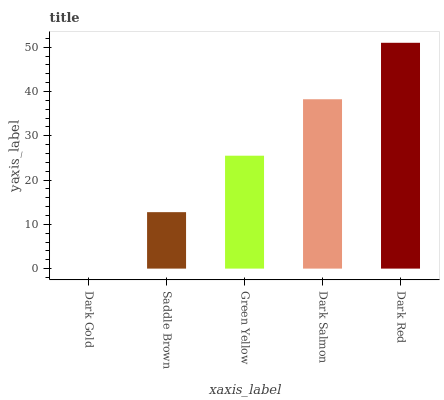Is Dark Gold the minimum?
Answer yes or no. Yes. Is Dark Red the maximum?
Answer yes or no. Yes. Is Saddle Brown the minimum?
Answer yes or no. No. Is Saddle Brown the maximum?
Answer yes or no. No. Is Saddle Brown greater than Dark Gold?
Answer yes or no. Yes. Is Dark Gold less than Saddle Brown?
Answer yes or no. Yes. Is Dark Gold greater than Saddle Brown?
Answer yes or no. No. Is Saddle Brown less than Dark Gold?
Answer yes or no. No. Is Green Yellow the high median?
Answer yes or no. Yes. Is Green Yellow the low median?
Answer yes or no. Yes. Is Dark Salmon the high median?
Answer yes or no. No. Is Saddle Brown the low median?
Answer yes or no. No. 